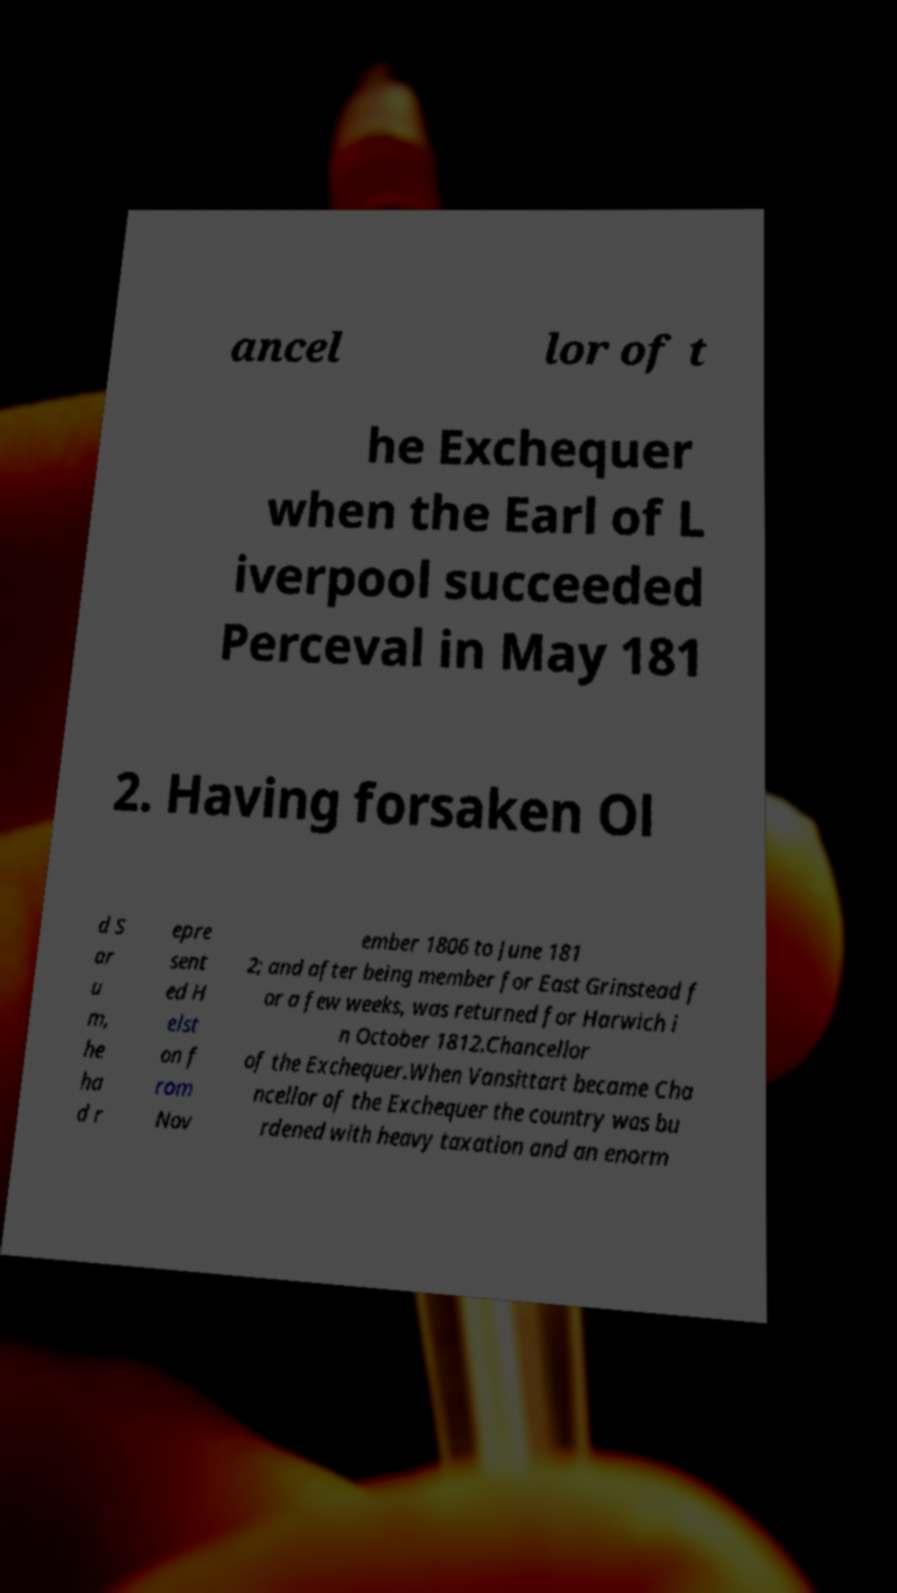I need the written content from this picture converted into text. Can you do that? ancel lor of t he Exchequer when the Earl of L iverpool succeeded Perceval in May 181 2. Having forsaken Ol d S ar u m, he ha d r epre sent ed H elst on f rom Nov ember 1806 to June 181 2; and after being member for East Grinstead f or a few weeks, was returned for Harwich i n October 1812.Chancellor of the Exchequer.When Vansittart became Cha ncellor of the Exchequer the country was bu rdened with heavy taxation and an enorm 